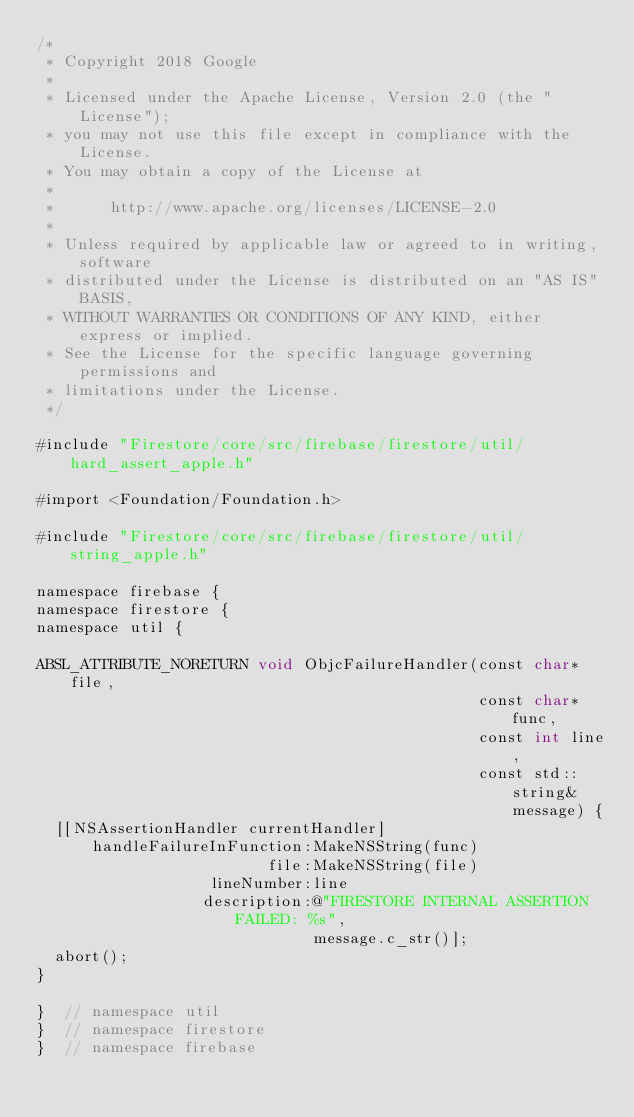Convert code to text. <code><loc_0><loc_0><loc_500><loc_500><_ObjectiveC_>/*
 * Copyright 2018 Google
 *
 * Licensed under the Apache License, Version 2.0 (the "License");
 * you may not use this file except in compliance with the License.
 * You may obtain a copy of the License at
 *
 *      http://www.apache.org/licenses/LICENSE-2.0
 *
 * Unless required by applicable law or agreed to in writing, software
 * distributed under the License is distributed on an "AS IS" BASIS,
 * WITHOUT WARRANTIES OR CONDITIONS OF ANY KIND, either express or implied.
 * See the License for the specific language governing permissions and
 * limitations under the License.
 */

#include "Firestore/core/src/firebase/firestore/util/hard_assert_apple.h"

#import <Foundation/Foundation.h>

#include "Firestore/core/src/firebase/firestore/util/string_apple.h"

namespace firebase {
namespace firestore {
namespace util {

ABSL_ATTRIBUTE_NORETURN void ObjcFailureHandler(const char* file,
                                                const char* func,
                                                const int line,
                                                const std::string& message) {
  [[NSAssertionHandler currentHandler]
      handleFailureInFunction:MakeNSString(func)
                         file:MakeNSString(file)
                   lineNumber:line
                  description:@"FIRESTORE INTERNAL ASSERTION FAILED: %s",
                              message.c_str()];
  abort();
}

}  // namespace util
}  // namespace firestore
}  // namespace firebase
</code> 